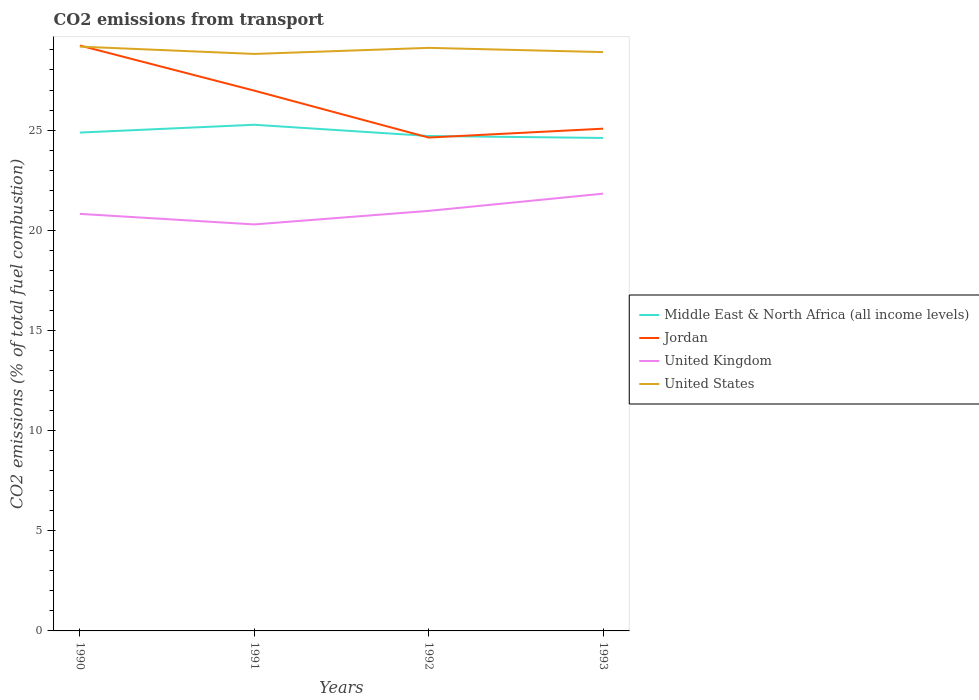Across all years, what is the maximum total CO2 emitted in United States?
Provide a short and direct response. 28.8. In which year was the total CO2 emitted in Jordan maximum?
Offer a very short reply. 1992. What is the total total CO2 emitted in Jordan in the graph?
Your answer should be very brief. 2.25. What is the difference between the highest and the second highest total CO2 emitted in United States?
Provide a succinct answer. 0.36. What is the difference between the highest and the lowest total CO2 emitted in Middle East & North Africa (all income levels)?
Keep it short and to the point. 2. How many lines are there?
Offer a terse response. 4. What is the difference between two consecutive major ticks on the Y-axis?
Make the answer very short. 5. Are the values on the major ticks of Y-axis written in scientific E-notation?
Keep it short and to the point. No. Does the graph contain any zero values?
Make the answer very short. No. Where does the legend appear in the graph?
Provide a short and direct response. Center right. How many legend labels are there?
Provide a short and direct response. 4. What is the title of the graph?
Give a very brief answer. CO2 emissions from transport. Does "Uruguay" appear as one of the legend labels in the graph?
Provide a succinct answer. No. What is the label or title of the Y-axis?
Your answer should be very brief. CO2 emissions (% of total fuel combustion). What is the CO2 emissions (% of total fuel combustion) of Middle East & North Africa (all income levels) in 1990?
Provide a succinct answer. 24.88. What is the CO2 emissions (% of total fuel combustion) of Jordan in 1990?
Provide a succinct answer. 29.22. What is the CO2 emissions (% of total fuel combustion) of United Kingdom in 1990?
Make the answer very short. 20.82. What is the CO2 emissions (% of total fuel combustion) of United States in 1990?
Keep it short and to the point. 29.17. What is the CO2 emissions (% of total fuel combustion) in Middle East & North Africa (all income levels) in 1991?
Provide a short and direct response. 25.26. What is the CO2 emissions (% of total fuel combustion) of Jordan in 1991?
Ensure brevity in your answer.  26.97. What is the CO2 emissions (% of total fuel combustion) in United Kingdom in 1991?
Offer a very short reply. 20.29. What is the CO2 emissions (% of total fuel combustion) in United States in 1991?
Provide a succinct answer. 28.8. What is the CO2 emissions (% of total fuel combustion) in Middle East & North Africa (all income levels) in 1992?
Your answer should be compact. 24.7. What is the CO2 emissions (% of total fuel combustion) in Jordan in 1992?
Your response must be concise. 24.63. What is the CO2 emissions (% of total fuel combustion) of United Kingdom in 1992?
Offer a terse response. 20.97. What is the CO2 emissions (% of total fuel combustion) of United States in 1992?
Offer a very short reply. 29.1. What is the CO2 emissions (% of total fuel combustion) in Middle East & North Africa (all income levels) in 1993?
Keep it short and to the point. 24.61. What is the CO2 emissions (% of total fuel combustion) of Jordan in 1993?
Your response must be concise. 25.07. What is the CO2 emissions (% of total fuel combustion) in United Kingdom in 1993?
Give a very brief answer. 21.83. What is the CO2 emissions (% of total fuel combustion) of United States in 1993?
Provide a succinct answer. 28.89. Across all years, what is the maximum CO2 emissions (% of total fuel combustion) of Middle East & North Africa (all income levels)?
Keep it short and to the point. 25.26. Across all years, what is the maximum CO2 emissions (% of total fuel combustion) of Jordan?
Your answer should be very brief. 29.22. Across all years, what is the maximum CO2 emissions (% of total fuel combustion) in United Kingdom?
Your response must be concise. 21.83. Across all years, what is the maximum CO2 emissions (% of total fuel combustion) in United States?
Provide a short and direct response. 29.17. Across all years, what is the minimum CO2 emissions (% of total fuel combustion) of Middle East & North Africa (all income levels)?
Offer a very short reply. 24.61. Across all years, what is the minimum CO2 emissions (% of total fuel combustion) in Jordan?
Make the answer very short. 24.63. Across all years, what is the minimum CO2 emissions (% of total fuel combustion) of United Kingdom?
Offer a very short reply. 20.29. Across all years, what is the minimum CO2 emissions (% of total fuel combustion) of United States?
Offer a terse response. 28.8. What is the total CO2 emissions (% of total fuel combustion) of Middle East & North Africa (all income levels) in the graph?
Provide a succinct answer. 99.45. What is the total CO2 emissions (% of total fuel combustion) in Jordan in the graph?
Give a very brief answer. 105.89. What is the total CO2 emissions (% of total fuel combustion) of United Kingdom in the graph?
Offer a very short reply. 83.9. What is the total CO2 emissions (% of total fuel combustion) in United States in the graph?
Provide a succinct answer. 115.96. What is the difference between the CO2 emissions (% of total fuel combustion) in Middle East & North Africa (all income levels) in 1990 and that in 1991?
Your answer should be very brief. -0.39. What is the difference between the CO2 emissions (% of total fuel combustion) in Jordan in 1990 and that in 1991?
Your response must be concise. 2.25. What is the difference between the CO2 emissions (% of total fuel combustion) of United Kingdom in 1990 and that in 1991?
Your answer should be compact. 0.53. What is the difference between the CO2 emissions (% of total fuel combustion) in United States in 1990 and that in 1991?
Your answer should be compact. 0.36. What is the difference between the CO2 emissions (% of total fuel combustion) of Middle East & North Africa (all income levels) in 1990 and that in 1992?
Offer a very short reply. 0.17. What is the difference between the CO2 emissions (% of total fuel combustion) of Jordan in 1990 and that in 1992?
Provide a short and direct response. 4.59. What is the difference between the CO2 emissions (% of total fuel combustion) of United Kingdom in 1990 and that in 1992?
Provide a short and direct response. -0.15. What is the difference between the CO2 emissions (% of total fuel combustion) of United States in 1990 and that in 1992?
Your answer should be compact. 0.06. What is the difference between the CO2 emissions (% of total fuel combustion) in Middle East & North Africa (all income levels) in 1990 and that in 1993?
Your answer should be compact. 0.27. What is the difference between the CO2 emissions (% of total fuel combustion) of Jordan in 1990 and that in 1993?
Give a very brief answer. 4.15. What is the difference between the CO2 emissions (% of total fuel combustion) in United Kingdom in 1990 and that in 1993?
Your answer should be compact. -1.01. What is the difference between the CO2 emissions (% of total fuel combustion) in United States in 1990 and that in 1993?
Keep it short and to the point. 0.27. What is the difference between the CO2 emissions (% of total fuel combustion) in Middle East & North Africa (all income levels) in 1991 and that in 1992?
Give a very brief answer. 0.56. What is the difference between the CO2 emissions (% of total fuel combustion) in Jordan in 1991 and that in 1992?
Your answer should be very brief. 2.34. What is the difference between the CO2 emissions (% of total fuel combustion) of United Kingdom in 1991 and that in 1992?
Provide a succinct answer. -0.68. What is the difference between the CO2 emissions (% of total fuel combustion) in United States in 1991 and that in 1992?
Make the answer very short. -0.3. What is the difference between the CO2 emissions (% of total fuel combustion) in Middle East & North Africa (all income levels) in 1991 and that in 1993?
Your response must be concise. 0.66. What is the difference between the CO2 emissions (% of total fuel combustion) in Jordan in 1991 and that in 1993?
Provide a succinct answer. 1.9. What is the difference between the CO2 emissions (% of total fuel combustion) in United Kingdom in 1991 and that in 1993?
Your answer should be compact. -1.54. What is the difference between the CO2 emissions (% of total fuel combustion) of United States in 1991 and that in 1993?
Make the answer very short. -0.09. What is the difference between the CO2 emissions (% of total fuel combustion) in Middle East & North Africa (all income levels) in 1992 and that in 1993?
Your answer should be very brief. 0.1. What is the difference between the CO2 emissions (% of total fuel combustion) in Jordan in 1992 and that in 1993?
Give a very brief answer. -0.44. What is the difference between the CO2 emissions (% of total fuel combustion) of United Kingdom in 1992 and that in 1993?
Offer a very short reply. -0.86. What is the difference between the CO2 emissions (% of total fuel combustion) of United States in 1992 and that in 1993?
Ensure brevity in your answer.  0.21. What is the difference between the CO2 emissions (% of total fuel combustion) in Middle East & North Africa (all income levels) in 1990 and the CO2 emissions (% of total fuel combustion) in Jordan in 1991?
Your answer should be very brief. -2.09. What is the difference between the CO2 emissions (% of total fuel combustion) of Middle East & North Africa (all income levels) in 1990 and the CO2 emissions (% of total fuel combustion) of United Kingdom in 1991?
Your answer should be compact. 4.59. What is the difference between the CO2 emissions (% of total fuel combustion) in Middle East & North Africa (all income levels) in 1990 and the CO2 emissions (% of total fuel combustion) in United States in 1991?
Give a very brief answer. -3.92. What is the difference between the CO2 emissions (% of total fuel combustion) of Jordan in 1990 and the CO2 emissions (% of total fuel combustion) of United Kingdom in 1991?
Your answer should be compact. 8.93. What is the difference between the CO2 emissions (% of total fuel combustion) of Jordan in 1990 and the CO2 emissions (% of total fuel combustion) of United States in 1991?
Offer a terse response. 0.42. What is the difference between the CO2 emissions (% of total fuel combustion) of United Kingdom in 1990 and the CO2 emissions (% of total fuel combustion) of United States in 1991?
Offer a terse response. -7.98. What is the difference between the CO2 emissions (% of total fuel combustion) in Middle East & North Africa (all income levels) in 1990 and the CO2 emissions (% of total fuel combustion) in Jordan in 1992?
Offer a very short reply. 0.25. What is the difference between the CO2 emissions (% of total fuel combustion) in Middle East & North Africa (all income levels) in 1990 and the CO2 emissions (% of total fuel combustion) in United Kingdom in 1992?
Offer a terse response. 3.91. What is the difference between the CO2 emissions (% of total fuel combustion) in Middle East & North Africa (all income levels) in 1990 and the CO2 emissions (% of total fuel combustion) in United States in 1992?
Keep it short and to the point. -4.23. What is the difference between the CO2 emissions (% of total fuel combustion) of Jordan in 1990 and the CO2 emissions (% of total fuel combustion) of United Kingdom in 1992?
Give a very brief answer. 8.25. What is the difference between the CO2 emissions (% of total fuel combustion) in Jordan in 1990 and the CO2 emissions (% of total fuel combustion) in United States in 1992?
Ensure brevity in your answer.  0.12. What is the difference between the CO2 emissions (% of total fuel combustion) in United Kingdom in 1990 and the CO2 emissions (% of total fuel combustion) in United States in 1992?
Provide a succinct answer. -8.29. What is the difference between the CO2 emissions (% of total fuel combustion) of Middle East & North Africa (all income levels) in 1990 and the CO2 emissions (% of total fuel combustion) of Jordan in 1993?
Provide a short and direct response. -0.19. What is the difference between the CO2 emissions (% of total fuel combustion) of Middle East & North Africa (all income levels) in 1990 and the CO2 emissions (% of total fuel combustion) of United Kingdom in 1993?
Your answer should be compact. 3.05. What is the difference between the CO2 emissions (% of total fuel combustion) of Middle East & North Africa (all income levels) in 1990 and the CO2 emissions (% of total fuel combustion) of United States in 1993?
Your answer should be very brief. -4.02. What is the difference between the CO2 emissions (% of total fuel combustion) of Jordan in 1990 and the CO2 emissions (% of total fuel combustion) of United Kingdom in 1993?
Offer a terse response. 7.39. What is the difference between the CO2 emissions (% of total fuel combustion) of Jordan in 1990 and the CO2 emissions (% of total fuel combustion) of United States in 1993?
Offer a terse response. 0.33. What is the difference between the CO2 emissions (% of total fuel combustion) of United Kingdom in 1990 and the CO2 emissions (% of total fuel combustion) of United States in 1993?
Your answer should be very brief. -8.07. What is the difference between the CO2 emissions (% of total fuel combustion) of Middle East & North Africa (all income levels) in 1991 and the CO2 emissions (% of total fuel combustion) of Jordan in 1992?
Your answer should be very brief. 0.64. What is the difference between the CO2 emissions (% of total fuel combustion) in Middle East & North Africa (all income levels) in 1991 and the CO2 emissions (% of total fuel combustion) in United Kingdom in 1992?
Provide a short and direct response. 4.3. What is the difference between the CO2 emissions (% of total fuel combustion) in Middle East & North Africa (all income levels) in 1991 and the CO2 emissions (% of total fuel combustion) in United States in 1992?
Your answer should be very brief. -3.84. What is the difference between the CO2 emissions (% of total fuel combustion) of Jordan in 1991 and the CO2 emissions (% of total fuel combustion) of United Kingdom in 1992?
Your answer should be compact. 6. What is the difference between the CO2 emissions (% of total fuel combustion) in Jordan in 1991 and the CO2 emissions (% of total fuel combustion) in United States in 1992?
Offer a very short reply. -2.14. What is the difference between the CO2 emissions (% of total fuel combustion) in United Kingdom in 1991 and the CO2 emissions (% of total fuel combustion) in United States in 1992?
Give a very brief answer. -8.81. What is the difference between the CO2 emissions (% of total fuel combustion) of Middle East & North Africa (all income levels) in 1991 and the CO2 emissions (% of total fuel combustion) of Jordan in 1993?
Provide a short and direct response. 0.2. What is the difference between the CO2 emissions (% of total fuel combustion) of Middle East & North Africa (all income levels) in 1991 and the CO2 emissions (% of total fuel combustion) of United Kingdom in 1993?
Your response must be concise. 3.44. What is the difference between the CO2 emissions (% of total fuel combustion) of Middle East & North Africa (all income levels) in 1991 and the CO2 emissions (% of total fuel combustion) of United States in 1993?
Your answer should be very brief. -3.63. What is the difference between the CO2 emissions (% of total fuel combustion) of Jordan in 1991 and the CO2 emissions (% of total fuel combustion) of United Kingdom in 1993?
Ensure brevity in your answer.  5.14. What is the difference between the CO2 emissions (% of total fuel combustion) of Jordan in 1991 and the CO2 emissions (% of total fuel combustion) of United States in 1993?
Give a very brief answer. -1.92. What is the difference between the CO2 emissions (% of total fuel combustion) of United Kingdom in 1991 and the CO2 emissions (% of total fuel combustion) of United States in 1993?
Make the answer very short. -8.6. What is the difference between the CO2 emissions (% of total fuel combustion) in Middle East & North Africa (all income levels) in 1992 and the CO2 emissions (% of total fuel combustion) in Jordan in 1993?
Make the answer very short. -0.36. What is the difference between the CO2 emissions (% of total fuel combustion) of Middle East & North Africa (all income levels) in 1992 and the CO2 emissions (% of total fuel combustion) of United Kingdom in 1993?
Give a very brief answer. 2.88. What is the difference between the CO2 emissions (% of total fuel combustion) of Middle East & North Africa (all income levels) in 1992 and the CO2 emissions (% of total fuel combustion) of United States in 1993?
Make the answer very short. -4.19. What is the difference between the CO2 emissions (% of total fuel combustion) in Jordan in 1992 and the CO2 emissions (% of total fuel combustion) in United Kingdom in 1993?
Your answer should be compact. 2.8. What is the difference between the CO2 emissions (% of total fuel combustion) in Jordan in 1992 and the CO2 emissions (% of total fuel combustion) in United States in 1993?
Offer a terse response. -4.27. What is the difference between the CO2 emissions (% of total fuel combustion) in United Kingdom in 1992 and the CO2 emissions (% of total fuel combustion) in United States in 1993?
Provide a short and direct response. -7.93. What is the average CO2 emissions (% of total fuel combustion) in Middle East & North Africa (all income levels) per year?
Keep it short and to the point. 24.86. What is the average CO2 emissions (% of total fuel combustion) in Jordan per year?
Give a very brief answer. 26.47. What is the average CO2 emissions (% of total fuel combustion) in United Kingdom per year?
Provide a succinct answer. 20.98. What is the average CO2 emissions (% of total fuel combustion) in United States per year?
Make the answer very short. 28.99. In the year 1990, what is the difference between the CO2 emissions (% of total fuel combustion) in Middle East & North Africa (all income levels) and CO2 emissions (% of total fuel combustion) in Jordan?
Keep it short and to the point. -4.34. In the year 1990, what is the difference between the CO2 emissions (% of total fuel combustion) of Middle East & North Africa (all income levels) and CO2 emissions (% of total fuel combustion) of United Kingdom?
Offer a very short reply. 4.06. In the year 1990, what is the difference between the CO2 emissions (% of total fuel combustion) in Middle East & North Africa (all income levels) and CO2 emissions (% of total fuel combustion) in United States?
Make the answer very short. -4.29. In the year 1990, what is the difference between the CO2 emissions (% of total fuel combustion) of Jordan and CO2 emissions (% of total fuel combustion) of United Kingdom?
Your answer should be compact. 8.4. In the year 1990, what is the difference between the CO2 emissions (% of total fuel combustion) of Jordan and CO2 emissions (% of total fuel combustion) of United States?
Offer a very short reply. 0.06. In the year 1990, what is the difference between the CO2 emissions (% of total fuel combustion) in United Kingdom and CO2 emissions (% of total fuel combustion) in United States?
Offer a terse response. -8.35. In the year 1991, what is the difference between the CO2 emissions (% of total fuel combustion) of Middle East & North Africa (all income levels) and CO2 emissions (% of total fuel combustion) of Jordan?
Make the answer very short. -1.7. In the year 1991, what is the difference between the CO2 emissions (% of total fuel combustion) of Middle East & North Africa (all income levels) and CO2 emissions (% of total fuel combustion) of United Kingdom?
Give a very brief answer. 4.97. In the year 1991, what is the difference between the CO2 emissions (% of total fuel combustion) of Middle East & North Africa (all income levels) and CO2 emissions (% of total fuel combustion) of United States?
Ensure brevity in your answer.  -3.54. In the year 1991, what is the difference between the CO2 emissions (% of total fuel combustion) of Jordan and CO2 emissions (% of total fuel combustion) of United Kingdom?
Your answer should be compact. 6.68. In the year 1991, what is the difference between the CO2 emissions (% of total fuel combustion) of Jordan and CO2 emissions (% of total fuel combustion) of United States?
Offer a terse response. -1.83. In the year 1991, what is the difference between the CO2 emissions (% of total fuel combustion) of United Kingdom and CO2 emissions (% of total fuel combustion) of United States?
Give a very brief answer. -8.51. In the year 1992, what is the difference between the CO2 emissions (% of total fuel combustion) in Middle East & North Africa (all income levels) and CO2 emissions (% of total fuel combustion) in Jordan?
Provide a short and direct response. 0.08. In the year 1992, what is the difference between the CO2 emissions (% of total fuel combustion) in Middle East & North Africa (all income levels) and CO2 emissions (% of total fuel combustion) in United Kingdom?
Keep it short and to the point. 3.74. In the year 1992, what is the difference between the CO2 emissions (% of total fuel combustion) of Middle East & North Africa (all income levels) and CO2 emissions (% of total fuel combustion) of United States?
Offer a terse response. -4.4. In the year 1992, what is the difference between the CO2 emissions (% of total fuel combustion) in Jordan and CO2 emissions (% of total fuel combustion) in United Kingdom?
Offer a terse response. 3.66. In the year 1992, what is the difference between the CO2 emissions (% of total fuel combustion) in Jordan and CO2 emissions (% of total fuel combustion) in United States?
Offer a terse response. -4.48. In the year 1992, what is the difference between the CO2 emissions (% of total fuel combustion) of United Kingdom and CO2 emissions (% of total fuel combustion) of United States?
Provide a succinct answer. -8.14. In the year 1993, what is the difference between the CO2 emissions (% of total fuel combustion) in Middle East & North Africa (all income levels) and CO2 emissions (% of total fuel combustion) in Jordan?
Ensure brevity in your answer.  -0.46. In the year 1993, what is the difference between the CO2 emissions (% of total fuel combustion) in Middle East & North Africa (all income levels) and CO2 emissions (% of total fuel combustion) in United Kingdom?
Keep it short and to the point. 2.78. In the year 1993, what is the difference between the CO2 emissions (% of total fuel combustion) of Middle East & North Africa (all income levels) and CO2 emissions (% of total fuel combustion) of United States?
Offer a very short reply. -4.29. In the year 1993, what is the difference between the CO2 emissions (% of total fuel combustion) of Jordan and CO2 emissions (% of total fuel combustion) of United Kingdom?
Keep it short and to the point. 3.24. In the year 1993, what is the difference between the CO2 emissions (% of total fuel combustion) of Jordan and CO2 emissions (% of total fuel combustion) of United States?
Provide a short and direct response. -3.82. In the year 1993, what is the difference between the CO2 emissions (% of total fuel combustion) in United Kingdom and CO2 emissions (% of total fuel combustion) in United States?
Keep it short and to the point. -7.07. What is the ratio of the CO2 emissions (% of total fuel combustion) in Middle East & North Africa (all income levels) in 1990 to that in 1991?
Offer a very short reply. 0.98. What is the ratio of the CO2 emissions (% of total fuel combustion) in Jordan in 1990 to that in 1991?
Keep it short and to the point. 1.08. What is the ratio of the CO2 emissions (% of total fuel combustion) of United States in 1990 to that in 1991?
Offer a terse response. 1.01. What is the ratio of the CO2 emissions (% of total fuel combustion) in Middle East & North Africa (all income levels) in 1990 to that in 1992?
Give a very brief answer. 1.01. What is the ratio of the CO2 emissions (% of total fuel combustion) in Jordan in 1990 to that in 1992?
Your answer should be compact. 1.19. What is the ratio of the CO2 emissions (% of total fuel combustion) of United Kingdom in 1990 to that in 1992?
Ensure brevity in your answer.  0.99. What is the ratio of the CO2 emissions (% of total fuel combustion) of United States in 1990 to that in 1992?
Keep it short and to the point. 1. What is the ratio of the CO2 emissions (% of total fuel combustion) in Middle East & North Africa (all income levels) in 1990 to that in 1993?
Your answer should be very brief. 1.01. What is the ratio of the CO2 emissions (% of total fuel combustion) of Jordan in 1990 to that in 1993?
Your response must be concise. 1.17. What is the ratio of the CO2 emissions (% of total fuel combustion) of United Kingdom in 1990 to that in 1993?
Offer a terse response. 0.95. What is the ratio of the CO2 emissions (% of total fuel combustion) in United States in 1990 to that in 1993?
Offer a terse response. 1.01. What is the ratio of the CO2 emissions (% of total fuel combustion) in Middle East & North Africa (all income levels) in 1991 to that in 1992?
Keep it short and to the point. 1.02. What is the ratio of the CO2 emissions (% of total fuel combustion) of Jordan in 1991 to that in 1992?
Offer a terse response. 1.1. What is the ratio of the CO2 emissions (% of total fuel combustion) in United Kingdom in 1991 to that in 1992?
Your answer should be very brief. 0.97. What is the ratio of the CO2 emissions (% of total fuel combustion) of Middle East & North Africa (all income levels) in 1991 to that in 1993?
Your answer should be very brief. 1.03. What is the ratio of the CO2 emissions (% of total fuel combustion) of Jordan in 1991 to that in 1993?
Provide a short and direct response. 1.08. What is the ratio of the CO2 emissions (% of total fuel combustion) in United Kingdom in 1991 to that in 1993?
Give a very brief answer. 0.93. What is the ratio of the CO2 emissions (% of total fuel combustion) of Middle East & North Africa (all income levels) in 1992 to that in 1993?
Provide a succinct answer. 1. What is the ratio of the CO2 emissions (% of total fuel combustion) in Jordan in 1992 to that in 1993?
Keep it short and to the point. 0.98. What is the ratio of the CO2 emissions (% of total fuel combustion) in United Kingdom in 1992 to that in 1993?
Your answer should be compact. 0.96. What is the ratio of the CO2 emissions (% of total fuel combustion) of United States in 1992 to that in 1993?
Provide a short and direct response. 1.01. What is the difference between the highest and the second highest CO2 emissions (% of total fuel combustion) of Middle East & North Africa (all income levels)?
Offer a terse response. 0.39. What is the difference between the highest and the second highest CO2 emissions (% of total fuel combustion) in Jordan?
Provide a short and direct response. 2.25. What is the difference between the highest and the second highest CO2 emissions (% of total fuel combustion) in United Kingdom?
Your response must be concise. 0.86. What is the difference between the highest and the second highest CO2 emissions (% of total fuel combustion) of United States?
Provide a short and direct response. 0.06. What is the difference between the highest and the lowest CO2 emissions (% of total fuel combustion) in Middle East & North Africa (all income levels)?
Ensure brevity in your answer.  0.66. What is the difference between the highest and the lowest CO2 emissions (% of total fuel combustion) of Jordan?
Your answer should be compact. 4.59. What is the difference between the highest and the lowest CO2 emissions (% of total fuel combustion) of United Kingdom?
Your answer should be very brief. 1.54. What is the difference between the highest and the lowest CO2 emissions (% of total fuel combustion) of United States?
Offer a terse response. 0.36. 